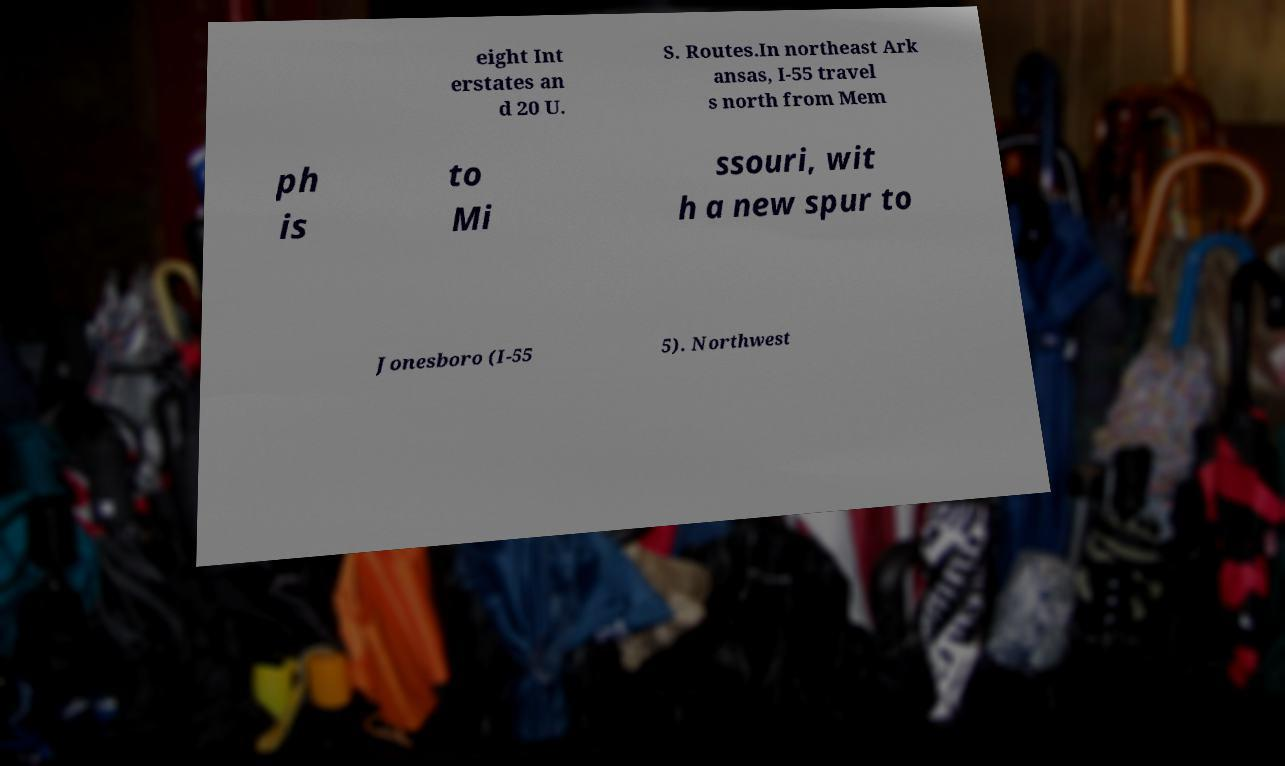Could you extract and type out the text from this image? eight Int erstates an d 20 U. S. Routes.In northeast Ark ansas, I-55 travel s north from Mem ph is to Mi ssouri, wit h a new spur to Jonesboro (I-55 5). Northwest 